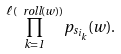Convert formula to latex. <formula><loc_0><loc_0><loc_500><loc_500>\prod _ { k = 1 } ^ { \ell ( \ r o l l ( w ) ) } p _ { s _ { i _ { k } } } ( w ) .</formula> 